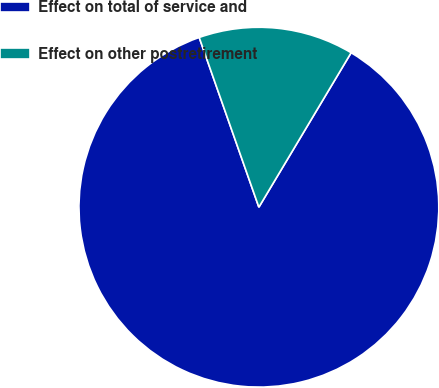Convert chart to OTSL. <chart><loc_0><loc_0><loc_500><loc_500><pie_chart><fcel>Effect on total of service and<fcel>Effect on other postretirement<nl><fcel>86.05%<fcel>13.95%<nl></chart> 